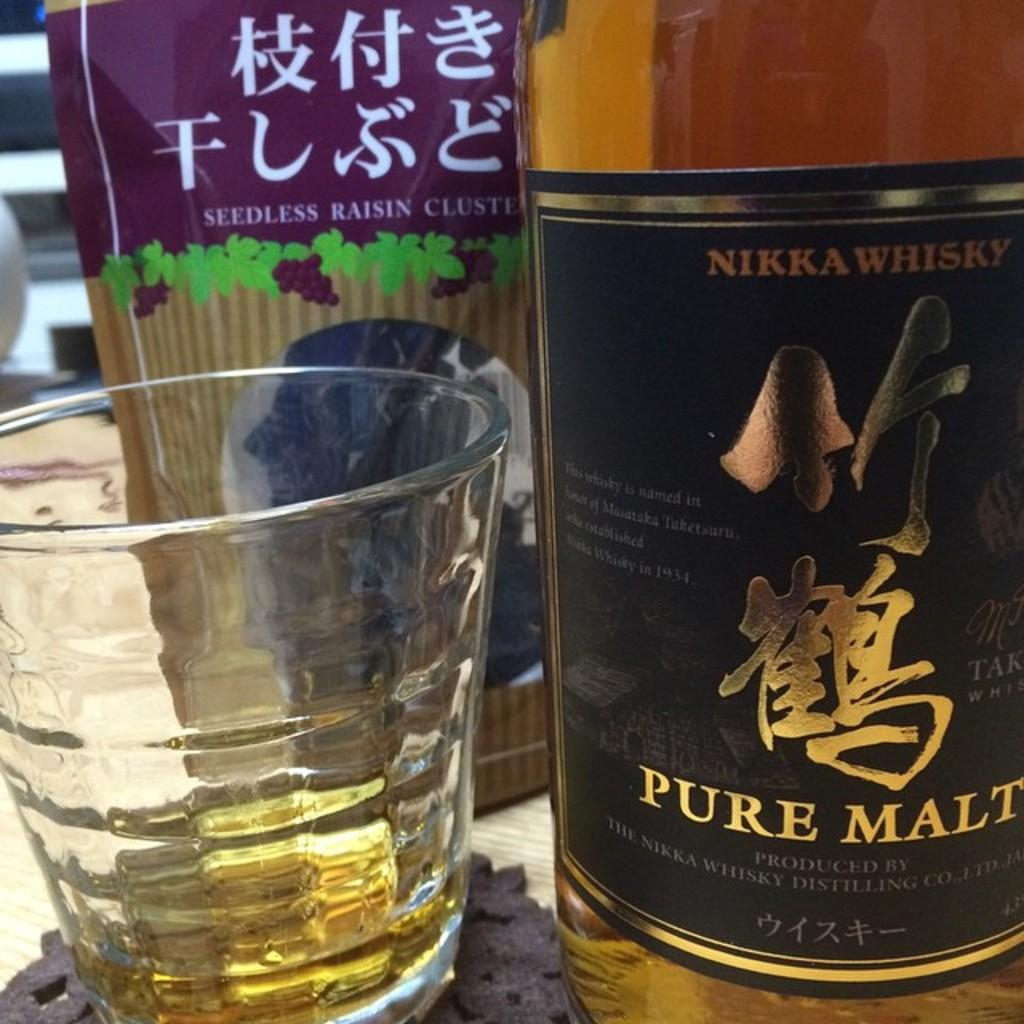What type of container is present in the image? There is a glass bottle in the image. What other glass-related object can be seen in the image? There is a glass in the image. How much does the salt weigh in the image? There is no salt present in the image, so it is not possible to determine its weight. 